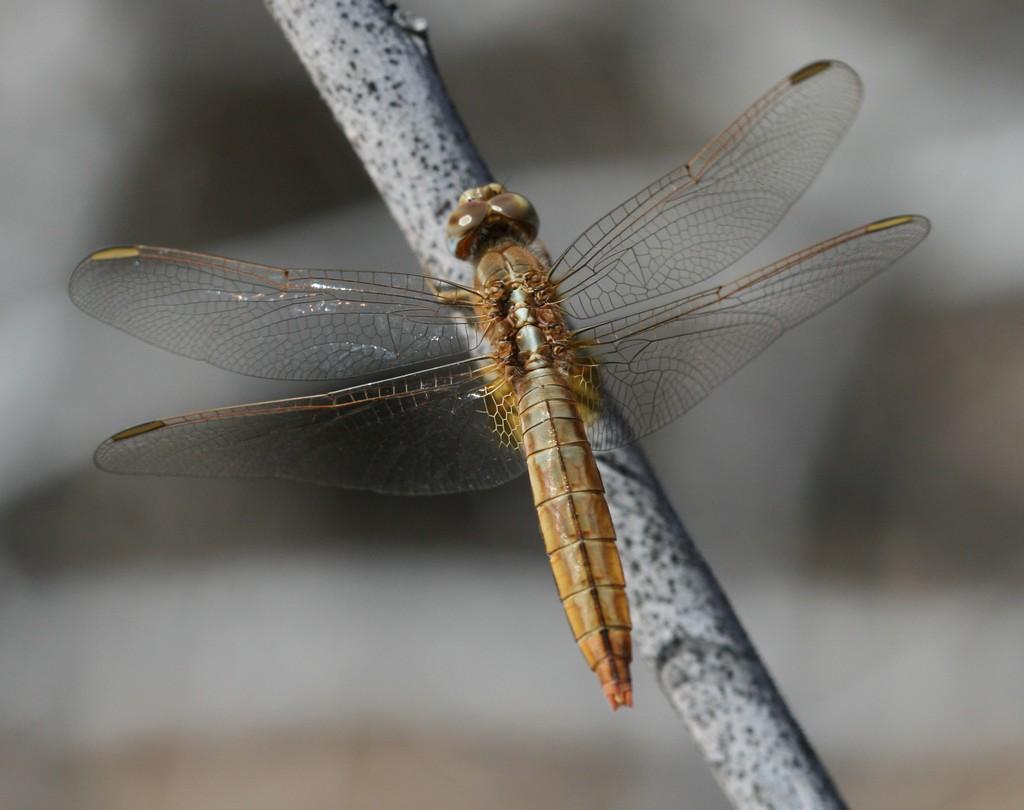Describe this image in one or two sentences. In the image there is a dragonfly standing on stem. 